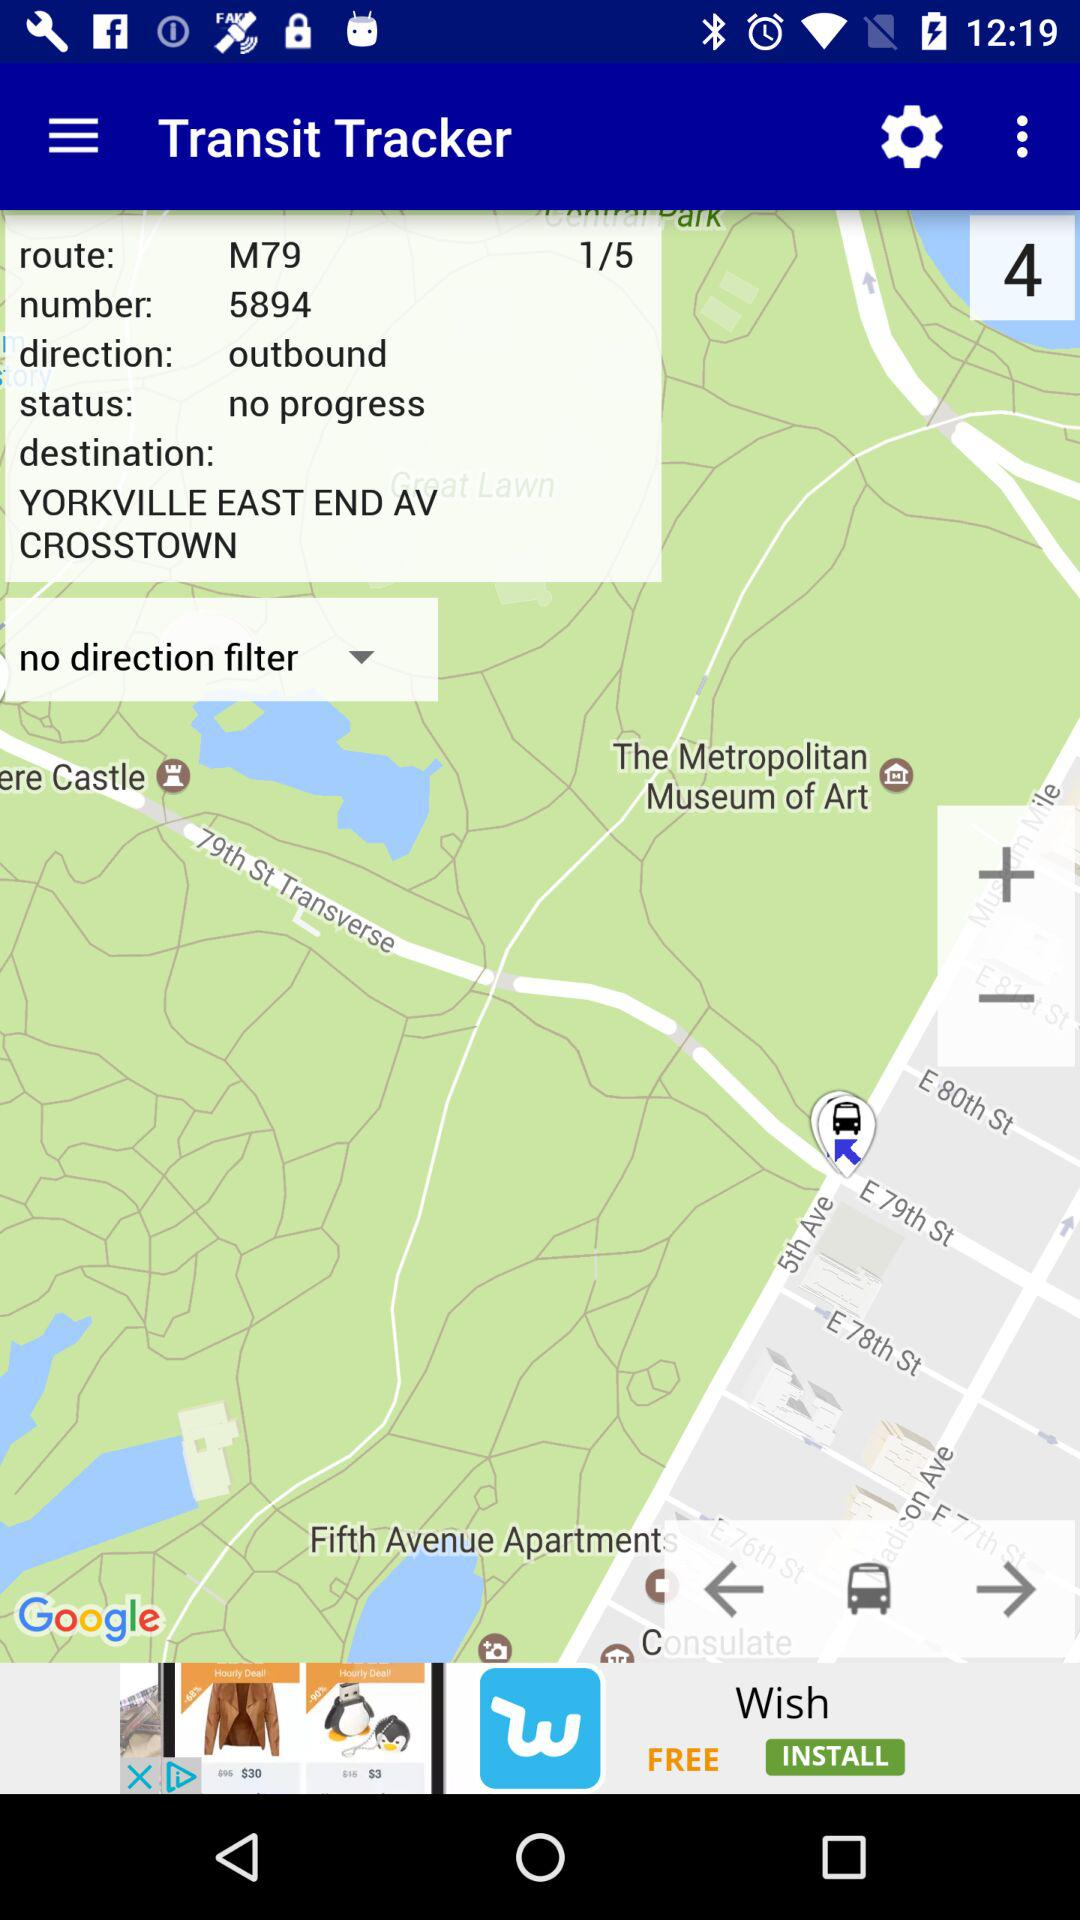What is the direction in the "Transit Tracker"? The direction in the "Transit Tracker" is "outbound". 